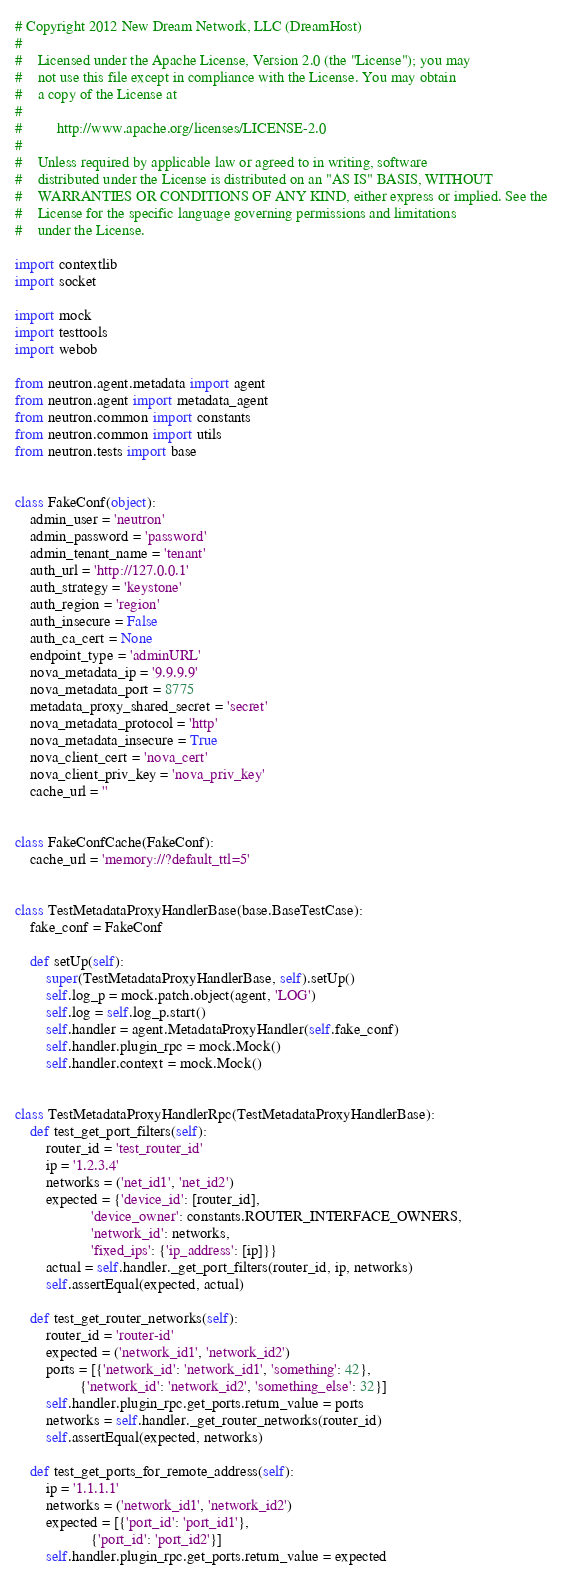<code> <loc_0><loc_0><loc_500><loc_500><_Python_># Copyright 2012 New Dream Network, LLC (DreamHost)
#
#    Licensed under the Apache License, Version 2.0 (the "License"); you may
#    not use this file except in compliance with the License. You may obtain
#    a copy of the License at
#
#         http://www.apache.org/licenses/LICENSE-2.0
#
#    Unless required by applicable law or agreed to in writing, software
#    distributed under the License is distributed on an "AS IS" BASIS, WITHOUT
#    WARRANTIES OR CONDITIONS OF ANY KIND, either express or implied. See the
#    License for the specific language governing permissions and limitations
#    under the License.

import contextlib
import socket

import mock
import testtools
import webob

from neutron.agent.metadata import agent
from neutron.agent import metadata_agent
from neutron.common import constants
from neutron.common import utils
from neutron.tests import base


class FakeConf(object):
    admin_user = 'neutron'
    admin_password = 'password'
    admin_tenant_name = 'tenant'
    auth_url = 'http://127.0.0.1'
    auth_strategy = 'keystone'
    auth_region = 'region'
    auth_insecure = False
    auth_ca_cert = None
    endpoint_type = 'adminURL'
    nova_metadata_ip = '9.9.9.9'
    nova_metadata_port = 8775
    metadata_proxy_shared_secret = 'secret'
    nova_metadata_protocol = 'http'
    nova_metadata_insecure = True
    nova_client_cert = 'nova_cert'
    nova_client_priv_key = 'nova_priv_key'
    cache_url = ''


class FakeConfCache(FakeConf):
    cache_url = 'memory://?default_ttl=5'


class TestMetadataProxyHandlerBase(base.BaseTestCase):
    fake_conf = FakeConf

    def setUp(self):
        super(TestMetadataProxyHandlerBase, self).setUp()
        self.log_p = mock.patch.object(agent, 'LOG')
        self.log = self.log_p.start()
        self.handler = agent.MetadataProxyHandler(self.fake_conf)
        self.handler.plugin_rpc = mock.Mock()
        self.handler.context = mock.Mock()


class TestMetadataProxyHandlerRpc(TestMetadataProxyHandlerBase):
    def test_get_port_filters(self):
        router_id = 'test_router_id'
        ip = '1.2.3.4'
        networks = ('net_id1', 'net_id2')
        expected = {'device_id': [router_id],
                    'device_owner': constants.ROUTER_INTERFACE_OWNERS,
                    'network_id': networks,
                    'fixed_ips': {'ip_address': [ip]}}
        actual = self.handler._get_port_filters(router_id, ip, networks)
        self.assertEqual(expected, actual)

    def test_get_router_networks(self):
        router_id = 'router-id'
        expected = ('network_id1', 'network_id2')
        ports = [{'network_id': 'network_id1', 'something': 42},
                 {'network_id': 'network_id2', 'something_else': 32}]
        self.handler.plugin_rpc.get_ports.return_value = ports
        networks = self.handler._get_router_networks(router_id)
        self.assertEqual(expected, networks)

    def test_get_ports_for_remote_address(self):
        ip = '1.1.1.1'
        networks = ('network_id1', 'network_id2')
        expected = [{'port_id': 'port_id1'},
                    {'port_id': 'port_id2'}]
        self.handler.plugin_rpc.get_ports.return_value = expected</code> 